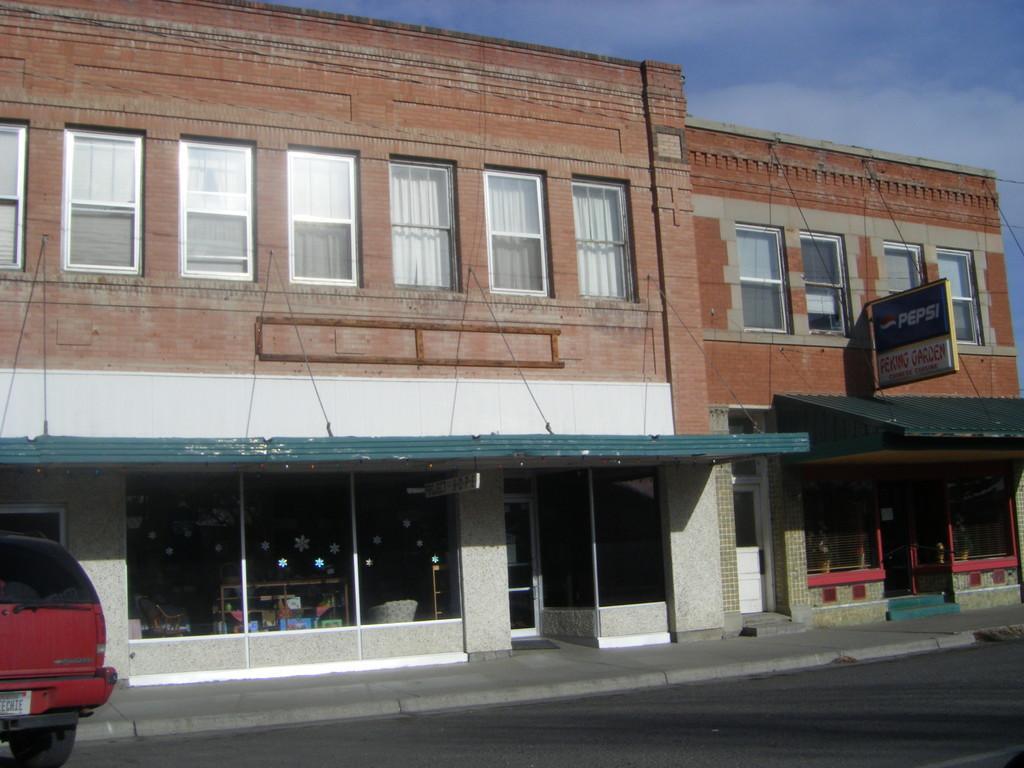Please provide a concise description of this image. In this picture we can see a vehicle on the road, buildings, board and windows. In the background of the image we can see the sky with clouds. 